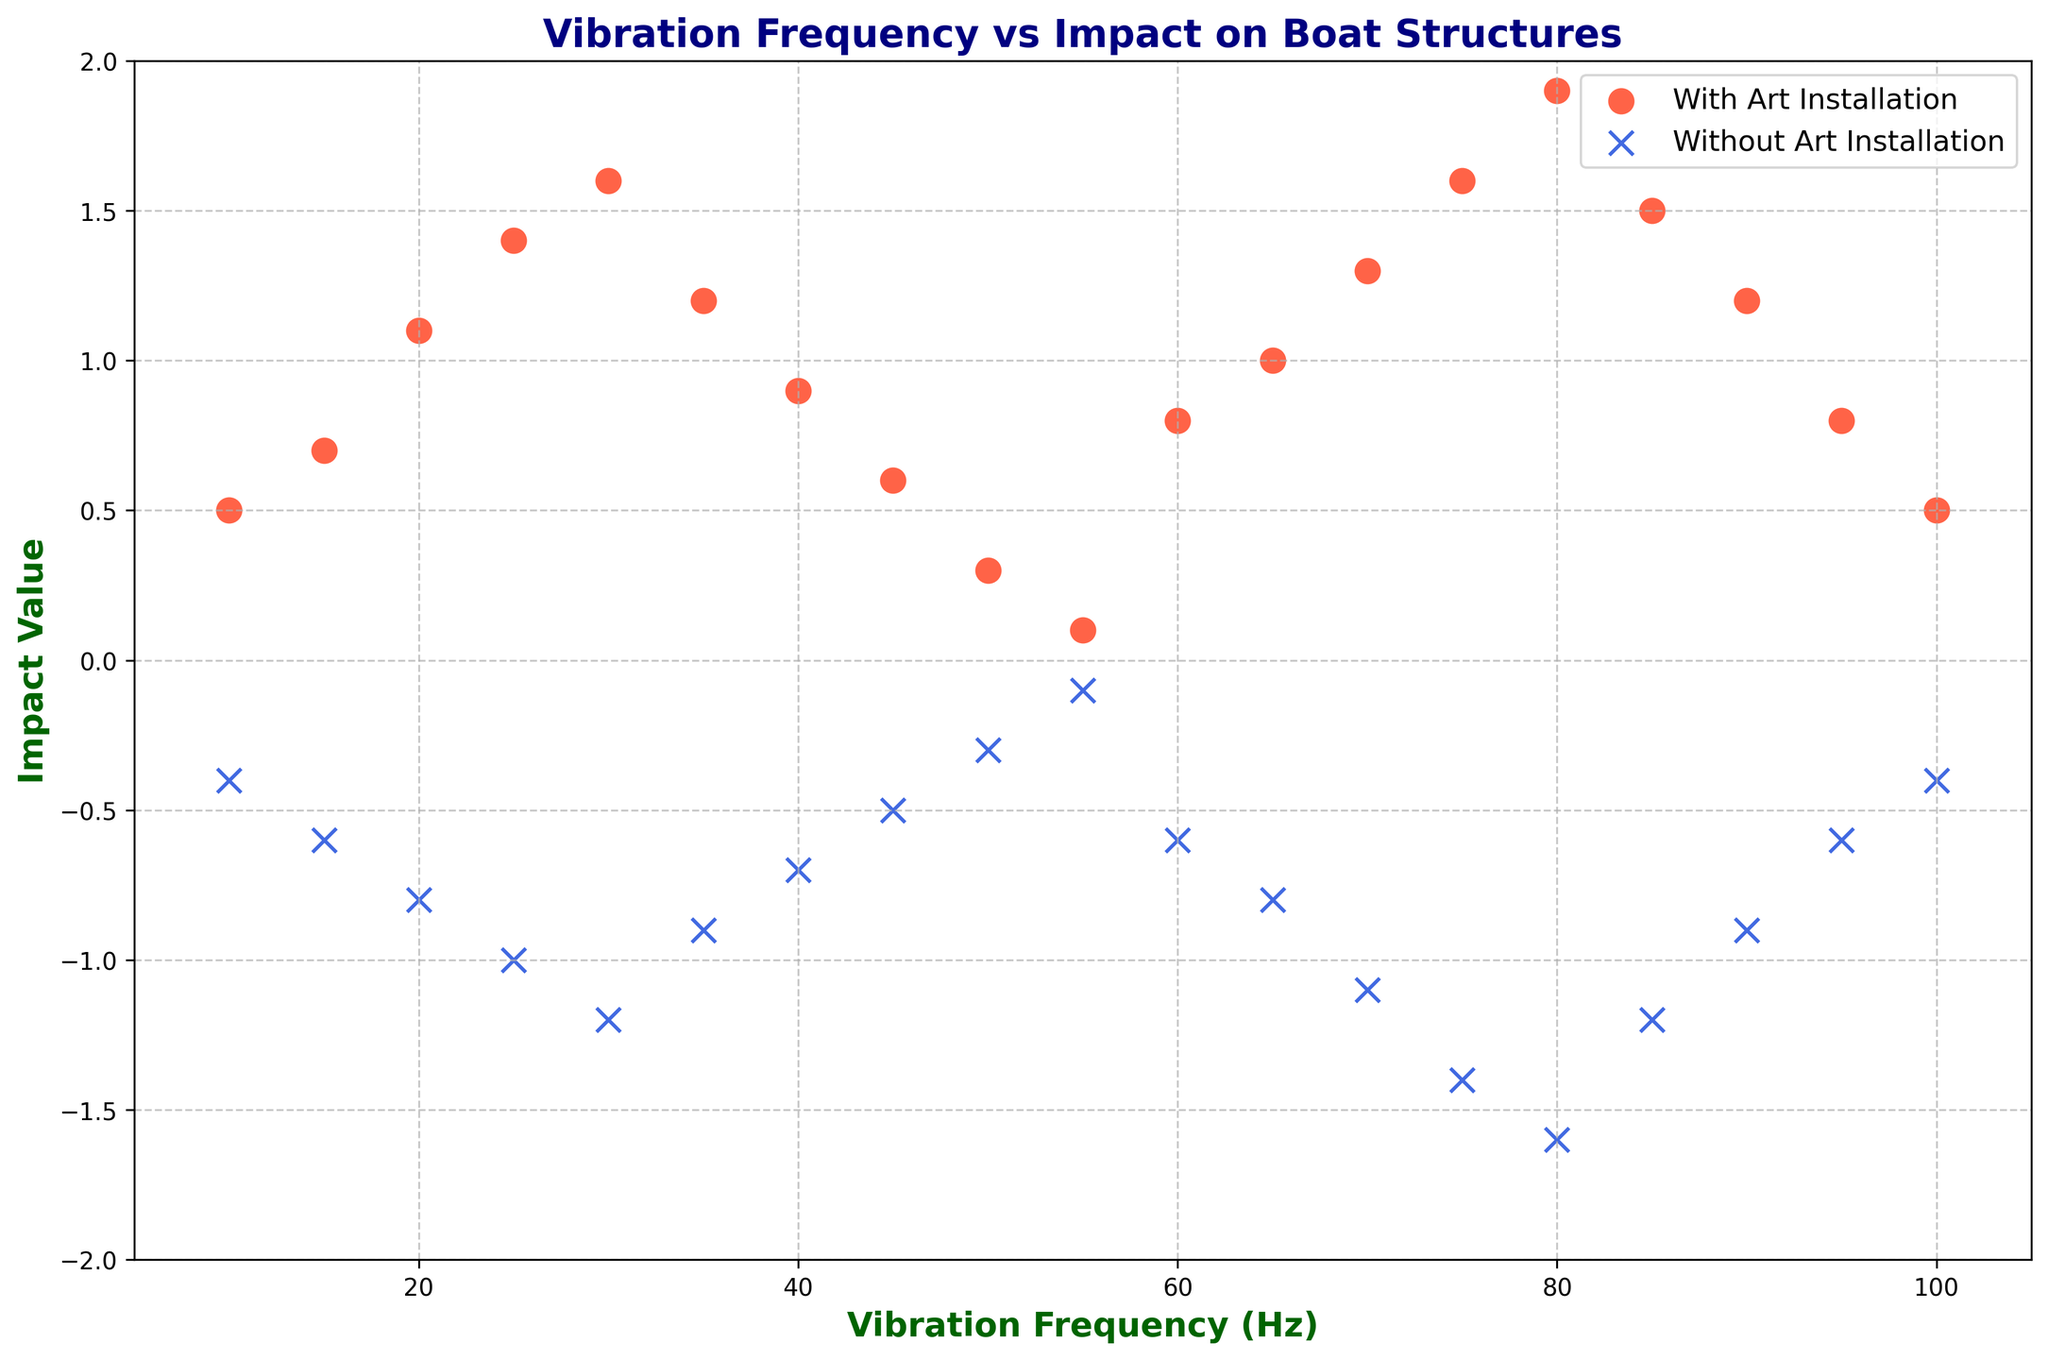What is the Impact Value at a Vibration Frequency of 20 Hz for boats with and without art installations? First, locate the data points for a vibration frequency of 20 Hz on the x-axis. Then, identify the Impact Values by checking the corresponding y-values. One data point (red circle) has an Impact Value of 1.1 (with art installation) and the other (blue x) has an Impact Value of -0.8 (without art installation).
Answer: With art installation: 1.1, Without art installation: -0.8 Which type of boat (with or without art installations) has a higher Impact Value at 30 Hz? Locate the data points at 30 Hz for both types. The red circle (with art installation) is at around 1.6, and the blue x (without art installation) is at -1.2. Compare the values to determine which is higher.
Answer: With art installation What is the general trend for the Impact Values of boats with art installations as Vibration Frequency increases from 10 Hz to 55 Hz? Identify the pattern followed by the red circles representing boats with art installations. The Impact Values start at 0.5 at 10 Hz, increase to a peak of 1.6 at 30 Hz, and then decrease to 0.1 at 55 Hz.
Answer: Increases to a peak at 30 Hz, then decreases Which Vibration Frequencies correspond to zero Impact Value for boats with art installations? Identify the red circles that intersect the x-axis (Impact Value of 0). There are no red circles that intersect directly at zero Impact Value, so none of the data points show an actual zero Impact Value.
Answer: None What is the difference in Impact Value between boats with and without art installations at 45 Hz? Locate the Impact Values at 45 Hz for both types of boats. The red circle shows an Impact Value of 0.6, and the blue x shows an Impact Value of -0.5. Calculate the difference: 0.6 - (-0.5) = 1.1.
Answer: 1.1 Comparing the peak Impact Values, which type of boats and at what Vibration Frequency do they occur? Find the highest points for red circles and blue x's. For boats with art installations, the peak is 1.9 at 80 Hz; for boats without art installations, the peak is -0.1 at 55 Hz.
Answer: With art installations at 80 Hz, Without art installations at 55 Hz What can be inferred about the stability of boats without art installations as Vibration Frequency increases? Observe the pattern of blue x's. The Impact Values for boats without art installations start at -0.4 at 10 Hz and become more negative up to -1.6 at 80 Hz, indicating increasing instability with higher frequencies until they somewhat decrease to -0.4 at 100 Hz.
Answer: Stability decreases with increased frequency What is the average Impact Value for boats with art installations at 30 Hz, 65 Hz, and 100 Hz? Identify the Impact Values for the red circles at these frequencies: 1.6 (30 Hz), 1.0 (65 Hz), and 0.5 (100 Hz). Calculate the average: (1.6 + 1.0 + 0.5) / 3 = 1.03.
Answer: 1.03 